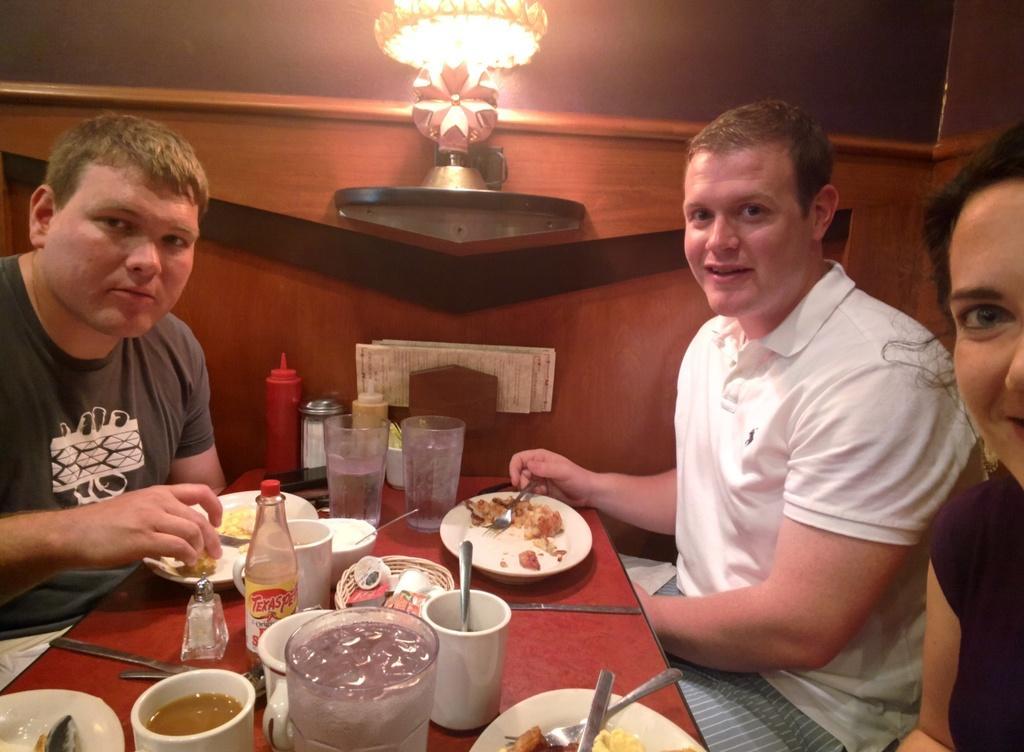Describe this image in one or two sentences. In this image, there are three persons sitting. At the bottom of the image, I can see the glasses, a bottle, cups, plates with food items, sauce bottles, forks, knives and few other things on a table. In the background, I can see a paper holder and a lamp attached to the wooden wall. 